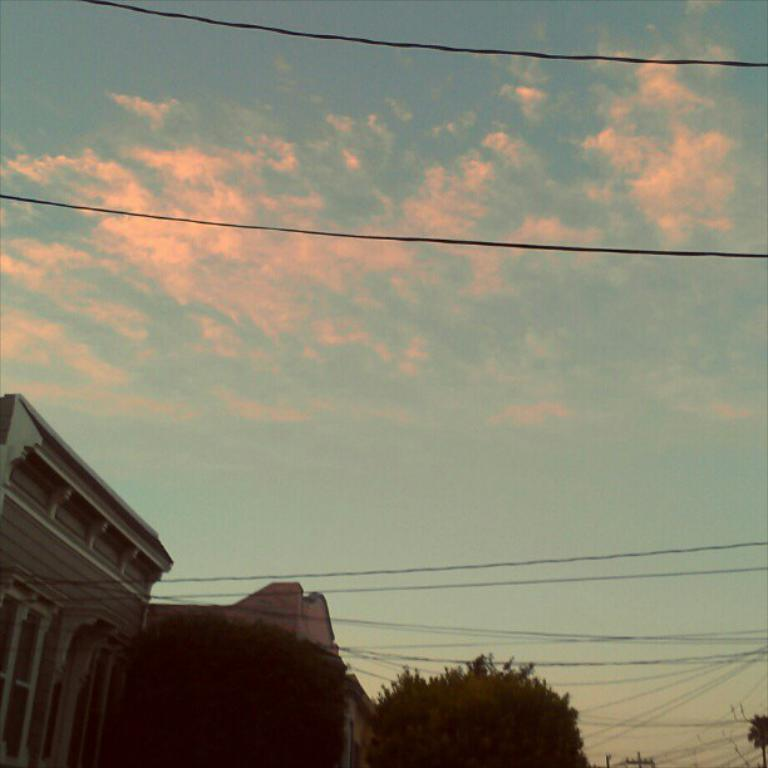What can be seen running through the image? There are cables in the image. What type of structures are present in the image? There are buildings in the image. What type of vegetation is visible in the image? There are trees in the image. What is visible in the background of the image? The sky is visible in the background of the image. Where is the powder located in the image? There is no powder present in the image. What type of hill can be seen in the image? There is no hill present in the image. 